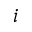<formula> <loc_0><loc_0><loc_500><loc_500>i</formula> 